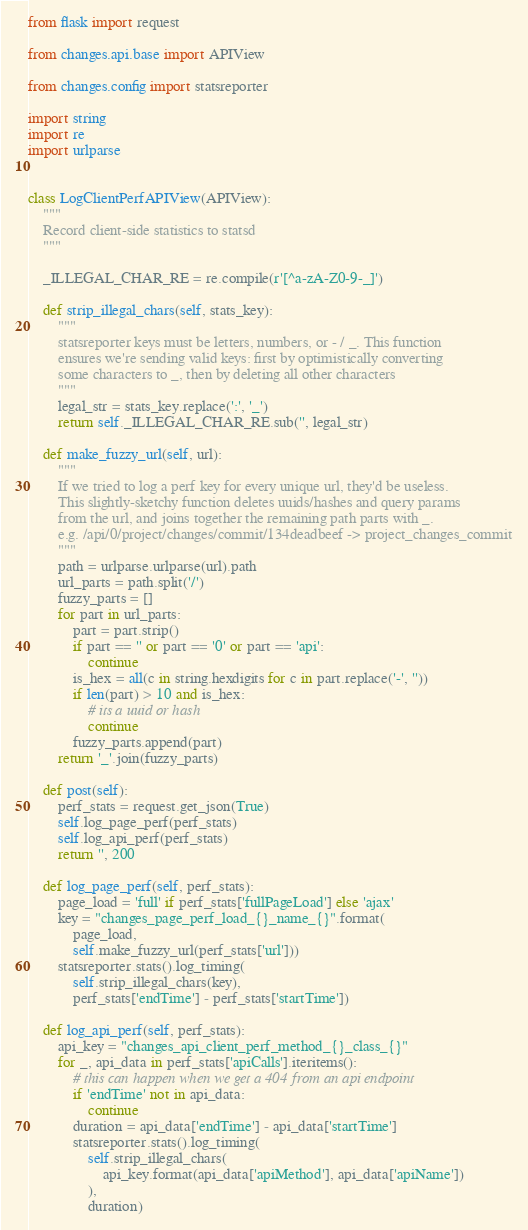Convert code to text. <code><loc_0><loc_0><loc_500><loc_500><_Python_>from flask import request

from changes.api.base import APIView

from changes.config import statsreporter

import string
import re
import urlparse


class LogClientPerfAPIView(APIView):
    """
    Record client-side statistics to statsd
    """

    _ILLEGAL_CHAR_RE = re.compile(r'[^a-zA-Z0-9-_]')

    def strip_illegal_chars(self, stats_key):
        """
        statsreporter keys must be letters, numbers, or - / _. This function
        ensures we're sending valid keys: first by optimistically converting
        some characters to _, then by deleting all other characters
        """
        legal_str = stats_key.replace(':', '_')
        return self._ILLEGAL_CHAR_RE.sub('', legal_str)

    def make_fuzzy_url(self, url):
        """
        If we tried to log a perf key for every unique url, they'd be useless.
        This slightly-sketchy function deletes uuids/hashes and query params
        from the url, and joins together the remaining path parts with _.
        e.g. /api/0/project/changes/commit/134deadbeef -> project_changes_commit
        """
        path = urlparse.urlparse(url).path
        url_parts = path.split('/')
        fuzzy_parts = []
        for part in url_parts:
            part = part.strip()
            if part == '' or part == '0' or part == 'api':
                continue
            is_hex = all(c in string.hexdigits for c in part.replace('-', ''))
            if len(part) > 10 and is_hex:
                # its a uuid or hash
                continue
            fuzzy_parts.append(part)
        return '_'.join(fuzzy_parts)

    def post(self):
        perf_stats = request.get_json(True)
        self.log_page_perf(perf_stats)
        self.log_api_perf(perf_stats)
        return '', 200

    def log_page_perf(self, perf_stats):
        page_load = 'full' if perf_stats['fullPageLoad'] else 'ajax'
        key = "changes_page_perf_load_{}_name_{}".format(
            page_load,
            self.make_fuzzy_url(perf_stats['url']))
        statsreporter.stats().log_timing(
            self.strip_illegal_chars(key),
            perf_stats['endTime'] - perf_stats['startTime'])

    def log_api_perf(self, perf_stats):
        api_key = "changes_api_client_perf_method_{}_class_{}"
        for _, api_data in perf_stats['apiCalls'].iteritems():
            # this can happen when we get a 404 from an api endpoint
            if 'endTime' not in api_data:
                continue
            duration = api_data['endTime'] - api_data['startTime']
            statsreporter.stats().log_timing(
                self.strip_illegal_chars(
                    api_key.format(api_data['apiMethod'], api_data['apiName'])
                ),
                duration)
</code> 